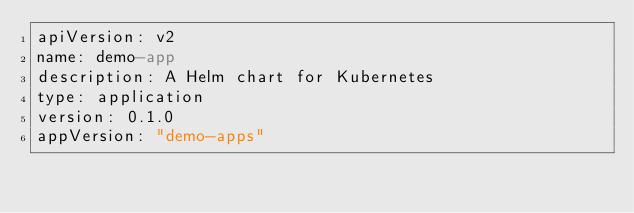Convert code to text. <code><loc_0><loc_0><loc_500><loc_500><_YAML_>apiVersion: v2
name: demo-app
description: A Helm chart for Kubernetes
type: application
version: 0.1.0
appVersion: "demo-apps"
</code> 